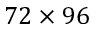Convert formula to latex. <formula><loc_0><loc_0><loc_500><loc_500>7 2 \times 9 6</formula> 